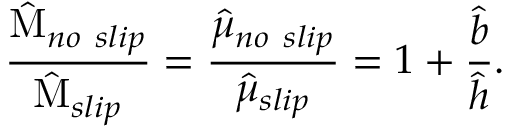Convert formula to latex. <formula><loc_0><loc_0><loc_500><loc_500>\frac { \hat { M } _ { n o \ s l i p } } { \hat { M } _ { s l i p } } = \frac { \hat { \mu } _ { n o \ s l i p } } { \hat { \mu } _ { s l i p } } = 1 + \frac { \hat { b } } { \hat { h } } .</formula> 